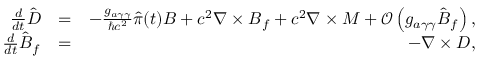Convert formula to latex. <formula><loc_0><loc_0><loc_500><loc_500>\begin{array} { r l r } { \frac { d } { d t } \hat { \boldsymbol D } } & { = } & { - \frac { g _ { a \gamma \gamma } } { \hbar { c } ^ { 2 } } \hat { \pi } ( t ) { \boldsymbol B } + c ^ { 2 } \boldsymbol \nabla \times { \boldsymbol B } _ { f } + c ^ { 2 } \boldsymbol \nabla \times { \boldsymbol M } + \mathcal { O } \left ( g _ { a \gamma \gamma } \hat { \boldsymbol B } _ { f } \right ) , } \\ { \frac { d } { d t } \hat { \boldsymbol B } _ { f } } & { = } & { - \boldsymbol \nabla \times { \boldsymbol D } , } \end{array}</formula> 